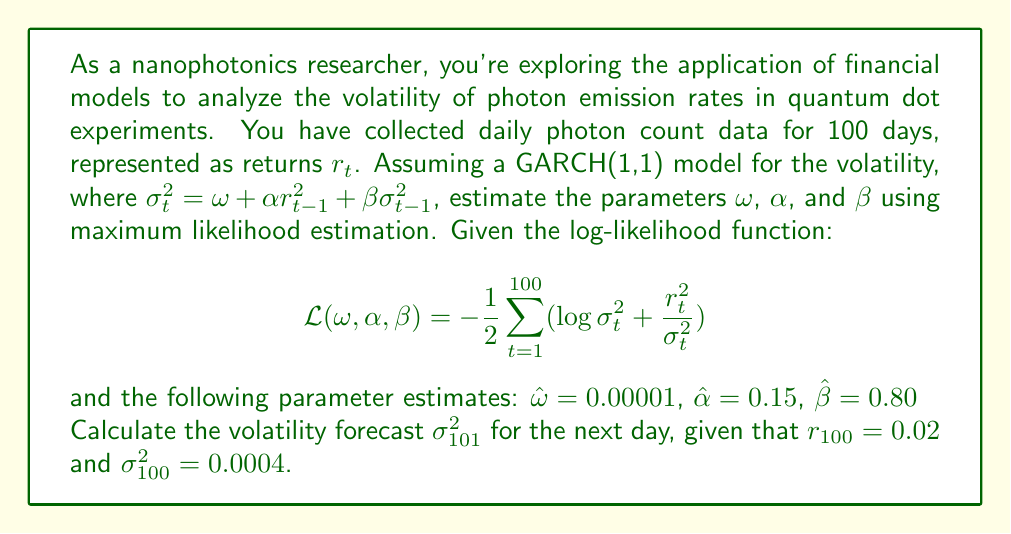Show me your answer to this math problem. To solve this problem, we'll follow these steps:

1. Understand the GARCH(1,1) model:
   The GARCH(1,1) model is given by:
   $$\sigma_t^2 = \omega + \alpha r_{t-1}^2 + \beta \sigma_{t-1}^2$$

2. Use the estimated parameters:
   $\hat{\omega} = 0.00001$
   $\hat{\alpha} = 0.15$
   $\hat{\beta} = 0.80$

3. Use the given information for day 100:
   $r_{100} = 0.02$
   $\sigma_{100}^2 = 0.0004$

4. Calculate $\sigma_{101}^2$ using the GARCH(1,1) formula:

   $$\begin{align}
   \sigma_{101}^2 &= \hat{\omega} + \hat{\alpha} r_{100}^2 + \hat{\beta} \sigma_{100}^2 \\
   &= 0.00001 + 0.15 \cdot (0.02)^2 + 0.80 \cdot 0.0004 \\
   &= 0.00001 + 0.15 \cdot 0.0004 + 0.80 \cdot 0.0004 \\
   &= 0.00001 + 0.00006 + 0.00032 \\
   &= 0.00039
   \end{align}$$

Thus, the volatility forecast for day 101 is $\sigma_{101}^2 = 0.00039$.
Answer: $\sigma_{101}^2 = 0.00039$ 